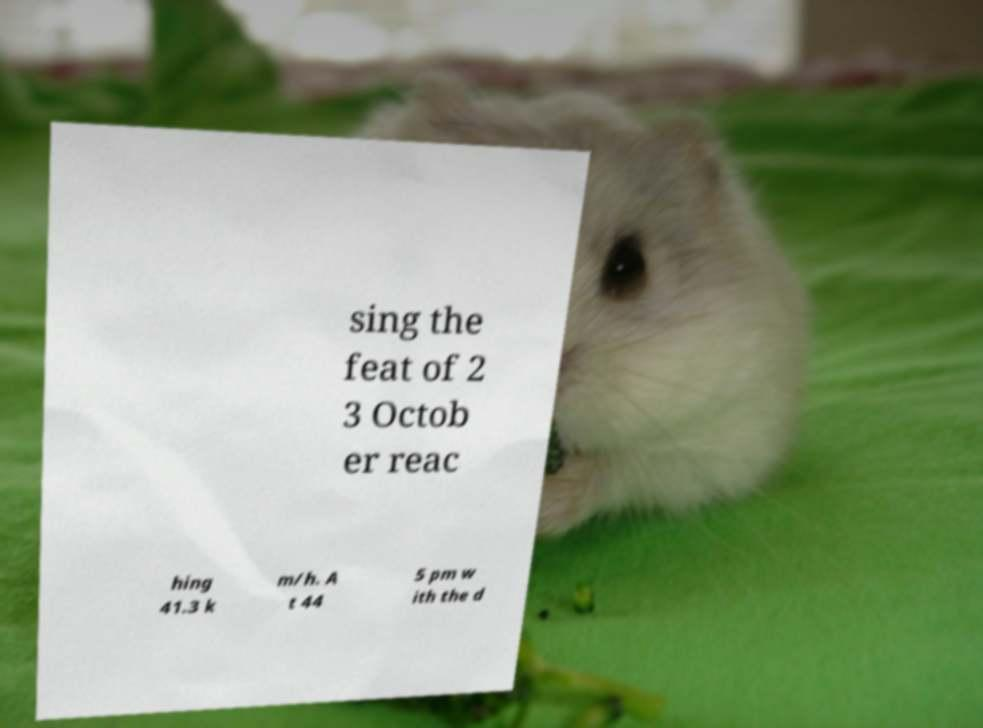Can you accurately transcribe the text from the provided image for me? sing the feat of 2 3 Octob er reac hing 41.3 k m/h. A t 44 5 pm w ith the d 